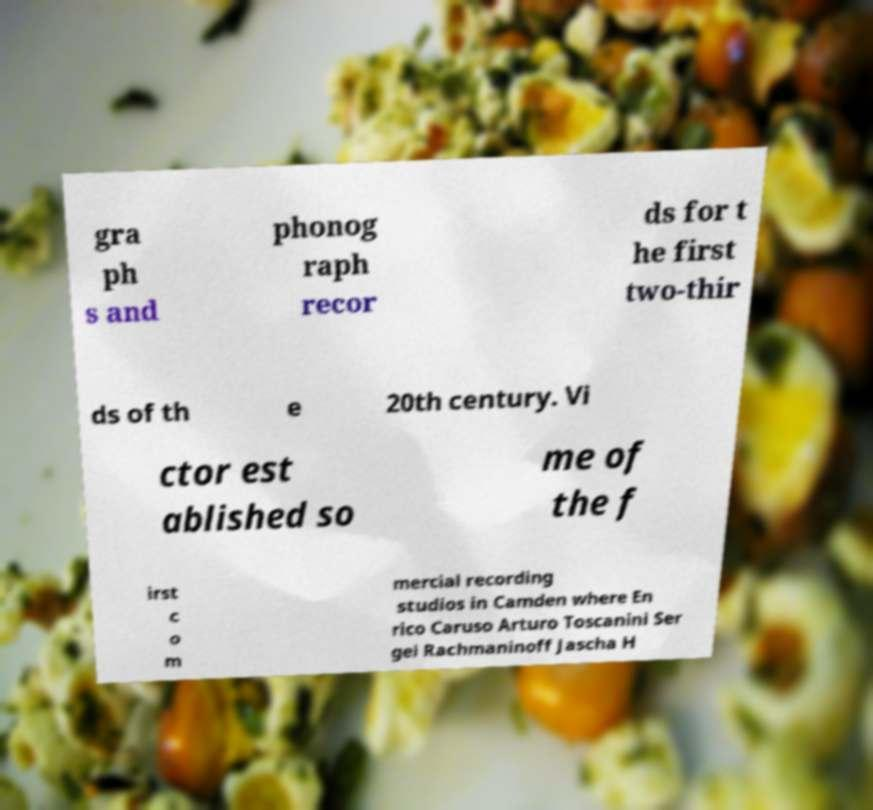Can you read and provide the text displayed in the image?This photo seems to have some interesting text. Can you extract and type it out for me? gra ph s and phonog raph recor ds for t he first two-thir ds of th e 20th century. Vi ctor est ablished so me of the f irst c o m mercial recording studios in Camden where En rico Caruso Arturo Toscanini Ser gei Rachmaninoff Jascha H 